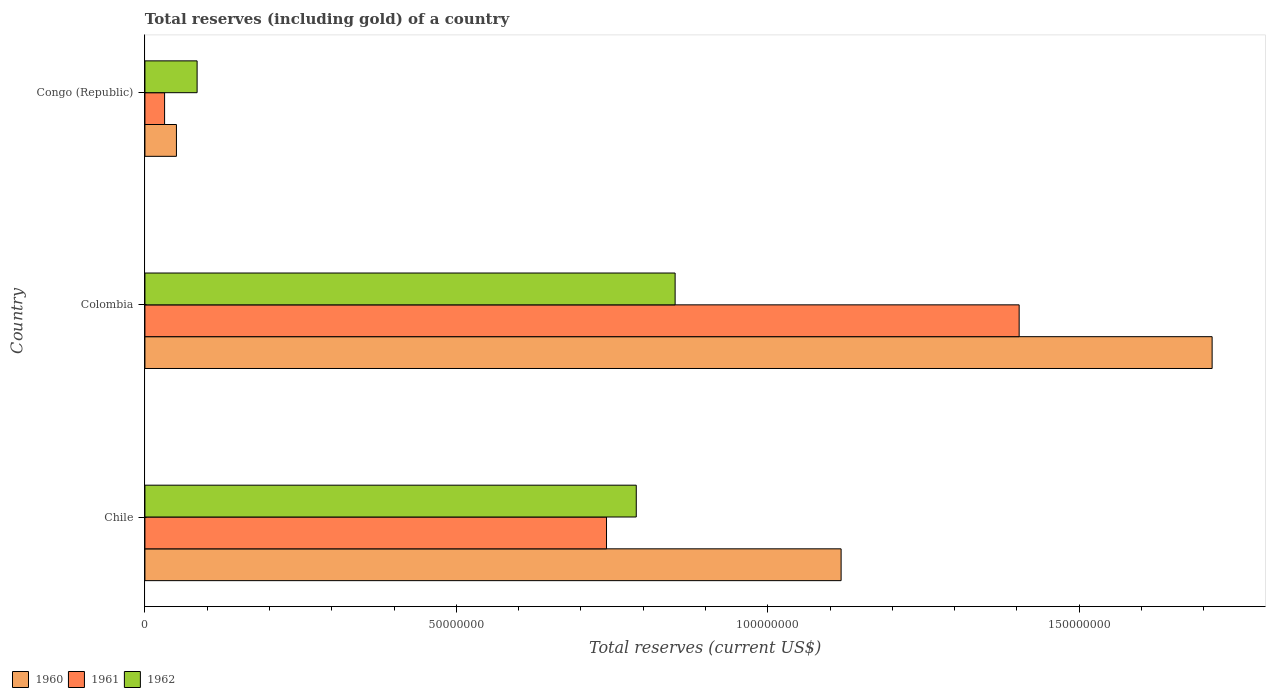Are the number of bars on each tick of the Y-axis equal?
Provide a succinct answer. Yes. How many bars are there on the 3rd tick from the bottom?
Your response must be concise. 3. What is the label of the 3rd group of bars from the top?
Your answer should be very brief. Chile. What is the total reserves (including gold) in 1960 in Chile?
Keep it short and to the point. 1.12e+08. Across all countries, what is the maximum total reserves (including gold) in 1960?
Your answer should be very brief. 1.71e+08. Across all countries, what is the minimum total reserves (including gold) in 1961?
Give a very brief answer. 3.16e+06. In which country was the total reserves (including gold) in 1960 minimum?
Offer a terse response. Congo (Republic). What is the total total reserves (including gold) in 1962 in the graph?
Give a very brief answer. 1.72e+08. What is the difference between the total reserves (including gold) in 1961 in Chile and that in Congo (Republic)?
Keep it short and to the point. 7.10e+07. What is the difference between the total reserves (including gold) in 1962 in Congo (Republic) and the total reserves (including gold) in 1960 in Colombia?
Give a very brief answer. -1.63e+08. What is the average total reserves (including gold) in 1961 per country?
Make the answer very short. 7.25e+07. What is the difference between the total reserves (including gold) in 1962 and total reserves (including gold) in 1960 in Chile?
Your answer should be very brief. -3.29e+07. What is the ratio of the total reserves (including gold) in 1961 in Chile to that in Colombia?
Provide a succinct answer. 0.53. Is the total reserves (including gold) in 1961 in Colombia less than that in Congo (Republic)?
Keep it short and to the point. No. Is the difference between the total reserves (including gold) in 1962 in Chile and Congo (Republic) greater than the difference between the total reserves (including gold) in 1960 in Chile and Congo (Republic)?
Your response must be concise. No. What is the difference between the highest and the second highest total reserves (including gold) in 1960?
Give a very brief answer. 5.96e+07. What is the difference between the highest and the lowest total reserves (including gold) in 1960?
Your answer should be compact. 1.66e+08. In how many countries, is the total reserves (including gold) in 1962 greater than the average total reserves (including gold) in 1962 taken over all countries?
Your answer should be very brief. 2. How many bars are there?
Give a very brief answer. 9. Are the values on the major ticks of X-axis written in scientific E-notation?
Your answer should be very brief. No. Does the graph contain grids?
Offer a terse response. No. What is the title of the graph?
Offer a terse response. Total reserves (including gold) of a country. Does "2014" appear as one of the legend labels in the graph?
Make the answer very short. No. What is the label or title of the X-axis?
Provide a succinct answer. Total reserves (current US$). What is the label or title of the Y-axis?
Ensure brevity in your answer.  Country. What is the Total reserves (current US$) in 1960 in Chile?
Your response must be concise. 1.12e+08. What is the Total reserves (current US$) in 1961 in Chile?
Your response must be concise. 7.41e+07. What is the Total reserves (current US$) of 1962 in Chile?
Your answer should be very brief. 7.89e+07. What is the Total reserves (current US$) in 1960 in Colombia?
Give a very brief answer. 1.71e+08. What is the Total reserves (current US$) of 1961 in Colombia?
Offer a very short reply. 1.40e+08. What is the Total reserves (current US$) of 1962 in Colombia?
Make the answer very short. 8.51e+07. What is the Total reserves (current US$) in 1960 in Congo (Republic)?
Offer a very short reply. 5.06e+06. What is the Total reserves (current US$) of 1961 in Congo (Republic)?
Keep it short and to the point. 3.16e+06. What is the Total reserves (current US$) of 1962 in Congo (Republic)?
Provide a succinct answer. 8.38e+06. Across all countries, what is the maximum Total reserves (current US$) of 1960?
Offer a very short reply. 1.71e+08. Across all countries, what is the maximum Total reserves (current US$) in 1961?
Give a very brief answer. 1.40e+08. Across all countries, what is the maximum Total reserves (current US$) of 1962?
Provide a succinct answer. 8.51e+07. Across all countries, what is the minimum Total reserves (current US$) in 1960?
Your answer should be compact. 5.06e+06. Across all countries, what is the minimum Total reserves (current US$) of 1961?
Make the answer very short. 3.16e+06. Across all countries, what is the minimum Total reserves (current US$) in 1962?
Your response must be concise. 8.38e+06. What is the total Total reserves (current US$) of 1960 in the graph?
Provide a short and direct response. 2.88e+08. What is the total Total reserves (current US$) of 1961 in the graph?
Your answer should be compact. 2.18e+08. What is the total Total reserves (current US$) in 1962 in the graph?
Give a very brief answer. 1.72e+08. What is the difference between the Total reserves (current US$) of 1960 in Chile and that in Colombia?
Offer a very short reply. -5.96e+07. What is the difference between the Total reserves (current US$) in 1961 in Chile and that in Colombia?
Offer a terse response. -6.63e+07. What is the difference between the Total reserves (current US$) of 1962 in Chile and that in Colombia?
Give a very brief answer. -6.24e+06. What is the difference between the Total reserves (current US$) in 1960 in Chile and that in Congo (Republic)?
Your answer should be very brief. 1.07e+08. What is the difference between the Total reserves (current US$) of 1961 in Chile and that in Congo (Republic)?
Your answer should be very brief. 7.10e+07. What is the difference between the Total reserves (current US$) in 1962 in Chile and that in Congo (Republic)?
Ensure brevity in your answer.  7.05e+07. What is the difference between the Total reserves (current US$) of 1960 in Colombia and that in Congo (Republic)?
Give a very brief answer. 1.66e+08. What is the difference between the Total reserves (current US$) of 1961 in Colombia and that in Congo (Republic)?
Ensure brevity in your answer.  1.37e+08. What is the difference between the Total reserves (current US$) of 1962 in Colombia and that in Congo (Republic)?
Offer a terse response. 7.67e+07. What is the difference between the Total reserves (current US$) of 1960 in Chile and the Total reserves (current US$) of 1961 in Colombia?
Your answer should be very brief. -2.86e+07. What is the difference between the Total reserves (current US$) in 1960 in Chile and the Total reserves (current US$) in 1962 in Colombia?
Keep it short and to the point. 2.67e+07. What is the difference between the Total reserves (current US$) of 1961 in Chile and the Total reserves (current US$) of 1962 in Colombia?
Your answer should be compact. -1.10e+07. What is the difference between the Total reserves (current US$) of 1960 in Chile and the Total reserves (current US$) of 1961 in Congo (Republic)?
Your answer should be compact. 1.09e+08. What is the difference between the Total reserves (current US$) of 1960 in Chile and the Total reserves (current US$) of 1962 in Congo (Republic)?
Keep it short and to the point. 1.03e+08. What is the difference between the Total reserves (current US$) in 1961 in Chile and the Total reserves (current US$) in 1962 in Congo (Republic)?
Your answer should be compact. 6.57e+07. What is the difference between the Total reserves (current US$) of 1960 in Colombia and the Total reserves (current US$) of 1961 in Congo (Republic)?
Offer a terse response. 1.68e+08. What is the difference between the Total reserves (current US$) in 1960 in Colombia and the Total reserves (current US$) in 1962 in Congo (Republic)?
Give a very brief answer. 1.63e+08. What is the difference between the Total reserves (current US$) in 1961 in Colombia and the Total reserves (current US$) in 1962 in Congo (Republic)?
Offer a terse response. 1.32e+08. What is the average Total reserves (current US$) of 1960 per country?
Offer a very short reply. 9.61e+07. What is the average Total reserves (current US$) in 1961 per country?
Give a very brief answer. 7.25e+07. What is the average Total reserves (current US$) of 1962 per country?
Offer a terse response. 5.75e+07. What is the difference between the Total reserves (current US$) of 1960 and Total reserves (current US$) of 1961 in Chile?
Provide a short and direct response. 3.77e+07. What is the difference between the Total reserves (current US$) in 1960 and Total reserves (current US$) in 1962 in Chile?
Your answer should be compact. 3.29e+07. What is the difference between the Total reserves (current US$) in 1961 and Total reserves (current US$) in 1962 in Chile?
Keep it short and to the point. -4.78e+06. What is the difference between the Total reserves (current US$) of 1960 and Total reserves (current US$) of 1961 in Colombia?
Ensure brevity in your answer.  3.10e+07. What is the difference between the Total reserves (current US$) in 1960 and Total reserves (current US$) in 1962 in Colombia?
Provide a short and direct response. 8.62e+07. What is the difference between the Total reserves (current US$) in 1961 and Total reserves (current US$) in 1962 in Colombia?
Provide a short and direct response. 5.52e+07. What is the difference between the Total reserves (current US$) of 1960 and Total reserves (current US$) of 1961 in Congo (Republic)?
Give a very brief answer. 1.90e+06. What is the difference between the Total reserves (current US$) in 1960 and Total reserves (current US$) in 1962 in Congo (Republic)?
Offer a very short reply. -3.32e+06. What is the difference between the Total reserves (current US$) in 1961 and Total reserves (current US$) in 1962 in Congo (Republic)?
Provide a succinct answer. -5.22e+06. What is the ratio of the Total reserves (current US$) in 1960 in Chile to that in Colombia?
Offer a very short reply. 0.65. What is the ratio of the Total reserves (current US$) in 1961 in Chile to that in Colombia?
Keep it short and to the point. 0.53. What is the ratio of the Total reserves (current US$) of 1962 in Chile to that in Colombia?
Provide a succinct answer. 0.93. What is the ratio of the Total reserves (current US$) of 1960 in Chile to that in Congo (Republic)?
Your answer should be compact. 22.09. What is the ratio of the Total reserves (current US$) of 1961 in Chile to that in Congo (Republic)?
Provide a short and direct response. 23.45. What is the ratio of the Total reserves (current US$) of 1962 in Chile to that in Congo (Republic)?
Your answer should be very brief. 9.41. What is the ratio of the Total reserves (current US$) of 1960 in Colombia to that in Congo (Republic)?
Keep it short and to the point. 33.86. What is the ratio of the Total reserves (current US$) of 1961 in Colombia to that in Congo (Republic)?
Keep it short and to the point. 44.42. What is the ratio of the Total reserves (current US$) of 1962 in Colombia to that in Congo (Republic)?
Offer a very short reply. 10.16. What is the difference between the highest and the second highest Total reserves (current US$) of 1960?
Your answer should be very brief. 5.96e+07. What is the difference between the highest and the second highest Total reserves (current US$) of 1961?
Your response must be concise. 6.63e+07. What is the difference between the highest and the second highest Total reserves (current US$) of 1962?
Keep it short and to the point. 6.24e+06. What is the difference between the highest and the lowest Total reserves (current US$) in 1960?
Keep it short and to the point. 1.66e+08. What is the difference between the highest and the lowest Total reserves (current US$) in 1961?
Make the answer very short. 1.37e+08. What is the difference between the highest and the lowest Total reserves (current US$) of 1962?
Provide a succinct answer. 7.67e+07. 